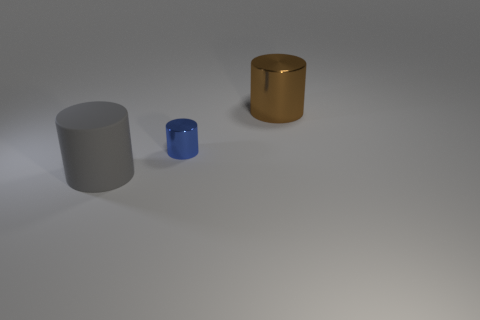Subtract all gray matte cylinders. How many cylinders are left? 2 Subtract all gray cylinders. How many cylinders are left? 2 Subtract 1 cylinders. How many cylinders are left? 2 Add 2 gray cylinders. How many gray cylinders are left? 3 Add 1 shiny things. How many shiny things exist? 3 Add 2 brown cylinders. How many objects exist? 5 Subtract 1 blue cylinders. How many objects are left? 2 Subtract all green cylinders. Subtract all red blocks. How many cylinders are left? 3 Subtract all brown blocks. How many gray cylinders are left? 1 Subtract all big gray shiny objects. Subtract all gray things. How many objects are left? 2 